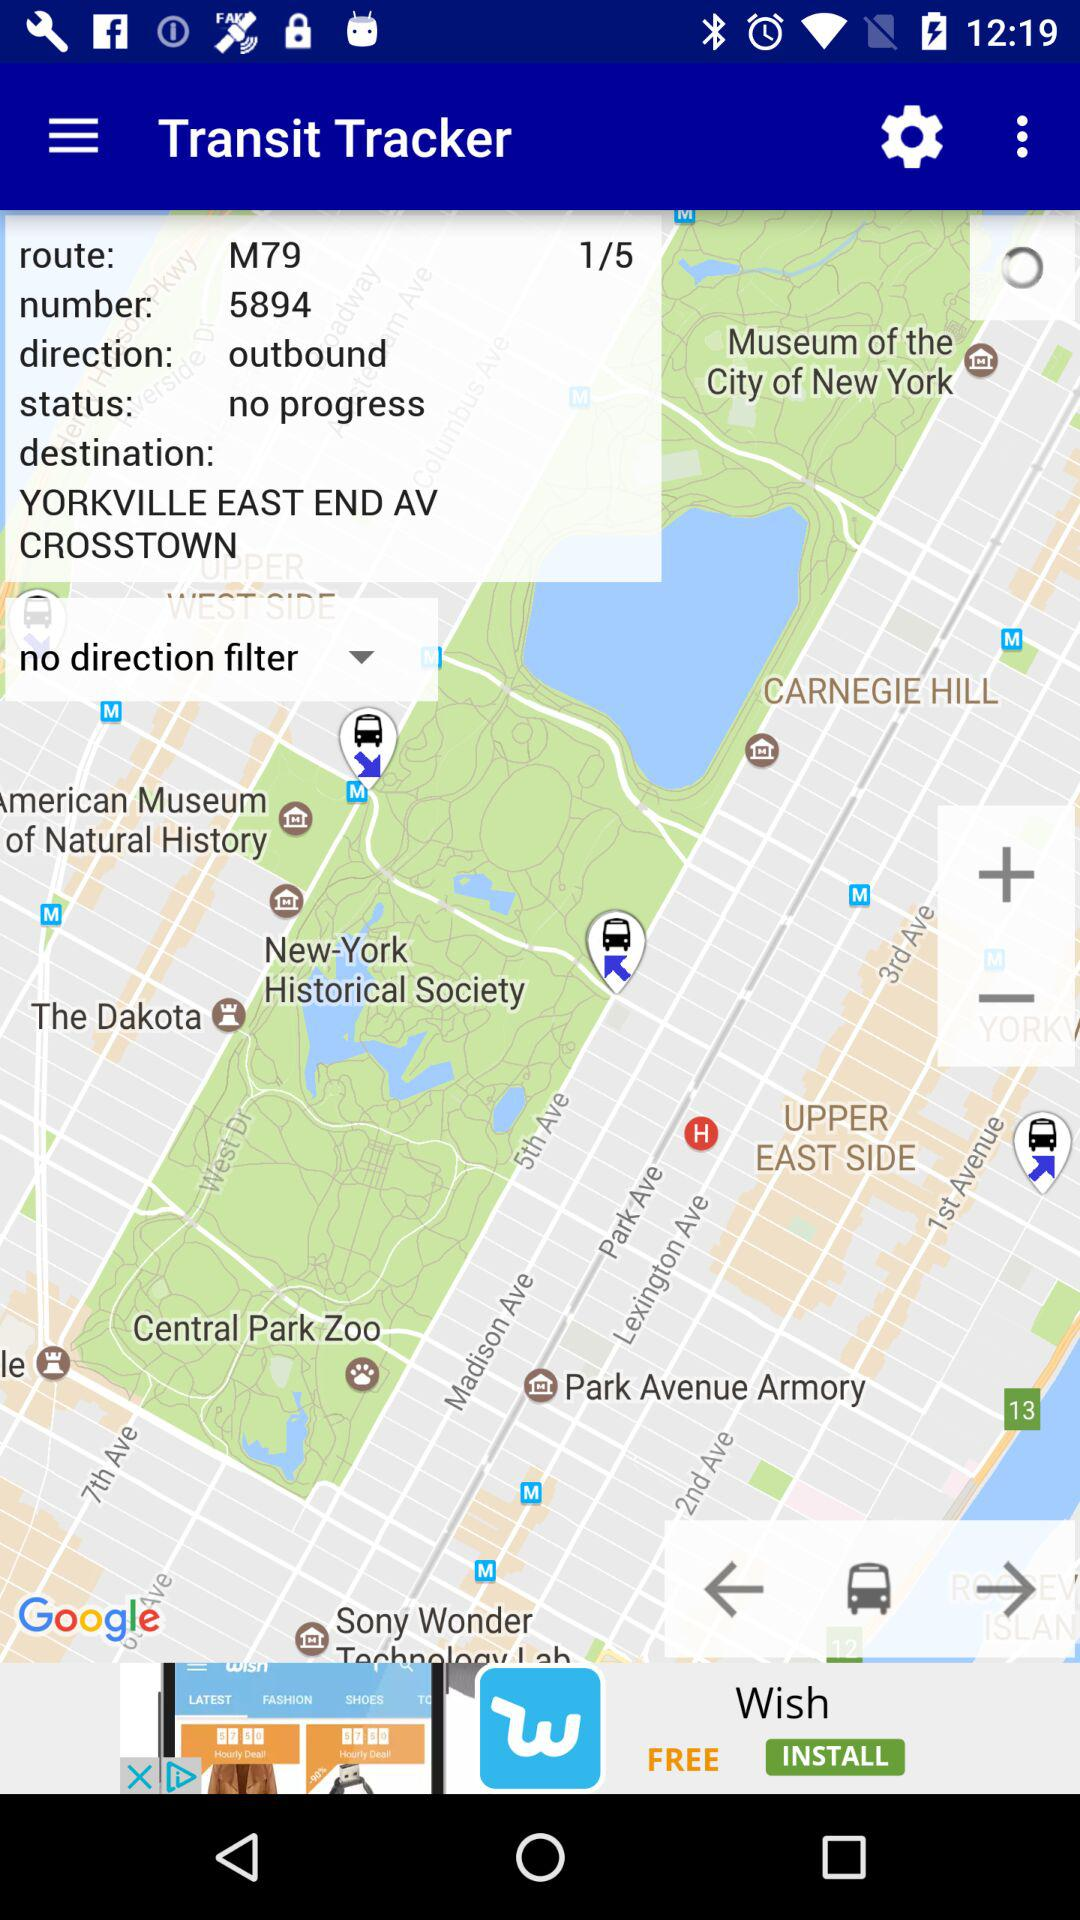What's the number? The number is 5894. 